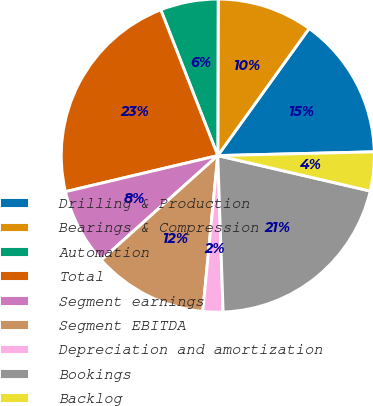Convert chart. <chart><loc_0><loc_0><loc_500><loc_500><pie_chart><fcel>Drilling & Production<fcel>Bearings & Compression<fcel>Automation<fcel>Total<fcel>Segment earnings<fcel>Segment EBITDA<fcel>Depreciation and amortization<fcel>Bookings<fcel>Backlog<nl><fcel>14.7%<fcel>9.88%<fcel>5.97%<fcel>22.77%<fcel>7.93%<fcel>11.84%<fcel>2.07%<fcel>20.82%<fcel>4.02%<nl></chart> 